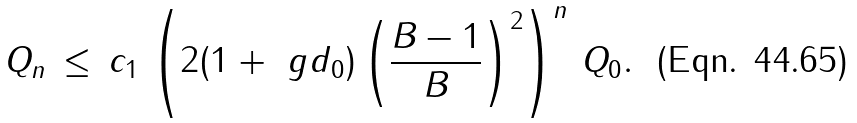Convert formula to latex. <formula><loc_0><loc_0><loc_500><loc_500>Q _ { n } \, \leq \, c _ { 1 } \, \left ( 2 ( 1 + \ g d _ { 0 } ) \left ( \frac { B - 1 } B \right ) ^ { 2 } \right ) ^ { n } \, Q _ { 0 } .</formula> 